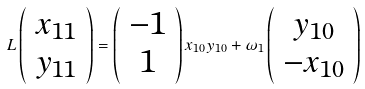<formula> <loc_0><loc_0><loc_500><loc_500>L \left ( \begin{array} { c } x _ { 1 1 } \\ y _ { 1 1 } \end{array} \right ) = \left ( \begin{array} { c } - 1 \\ 1 \end{array} \right ) x _ { 1 0 } y _ { 1 0 } + \omega _ { 1 } \left ( \begin{array} { c } y _ { 1 0 } \\ - x _ { 1 0 } \end{array} \right )</formula> 